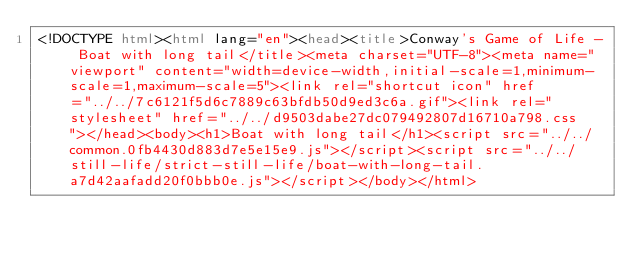Convert code to text. <code><loc_0><loc_0><loc_500><loc_500><_HTML_><!DOCTYPE html><html lang="en"><head><title>Conway's Game of Life - Boat with long tail</title><meta charset="UTF-8"><meta name="viewport" content="width=device-width,initial-scale=1,minimum-scale=1,maximum-scale=5"><link rel="shortcut icon" href="../../7c6121f5d6c7889c63bfdb50d9ed3c6a.gif"><link rel="stylesheet" href="../../d9503dabe27dc079492807d16710a798.css"></head><body><h1>Boat with long tail</h1><script src="../../common.0fb4430d883d7e5e15e9.js"></script><script src="../../still-life/strict-still-life/boat-with-long-tail.a7d42aafadd20f0bbb0e.js"></script></body></html></code> 